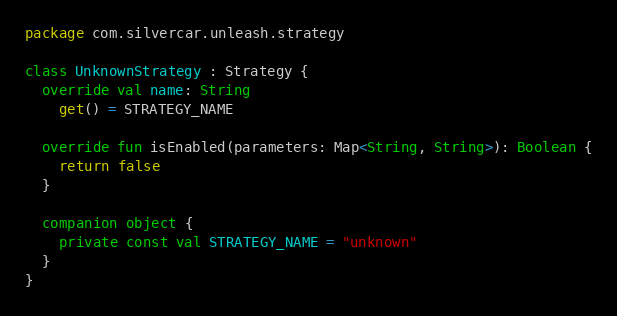Convert code to text. <code><loc_0><loc_0><loc_500><loc_500><_Kotlin_>package com.silvercar.unleash.strategy

class UnknownStrategy : Strategy {
  override val name: String
    get() = STRATEGY_NAME

  override fun isEnabled(parameters: Map<String, String>): Boolean {
    return false
  }

  companion object {
    private const val STRATEGY_NAME = "unknown"
  }
}
</code> 